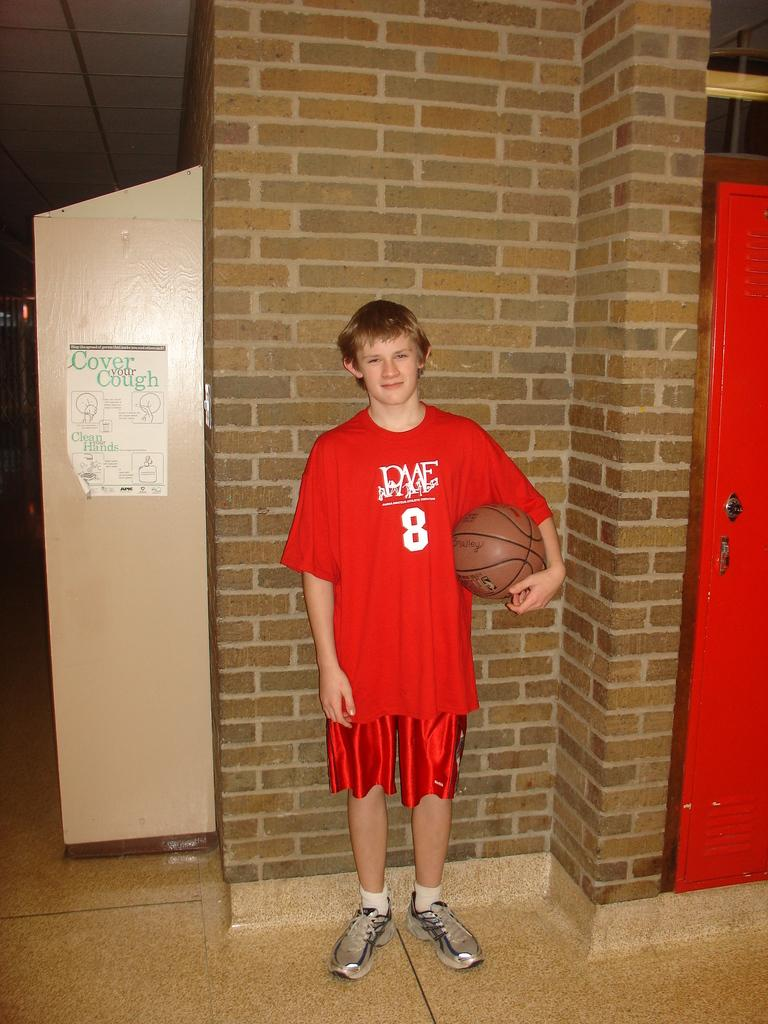<image>
Create a compact narrative representing the image presented. A kid wearing a red basket ball shirt that says PAAE number 8 on it 